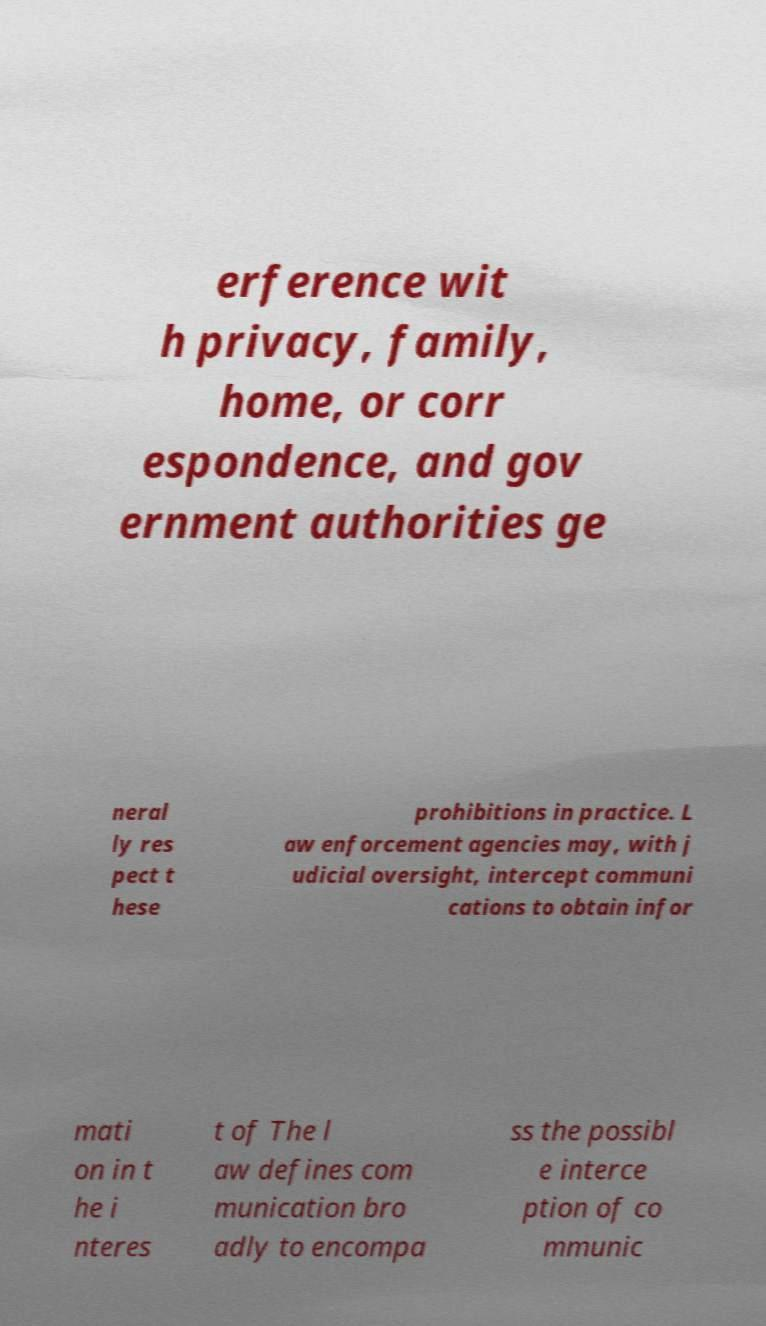Can you read and provide the text displayed in the image?This photo seems to have some interesting text. Can you extract and type it out for me? erference wit h privacy, family, home, or corr espondence, and gov ernment authorities ge neral ly res pect t hese prohibitions in practice. L aw enforcement agencies may, with j udicial oversight, intercept communi cations to obtain infor mati on in t he i nteres t of The l aw defines com munication bro adly to encompa ss the possibl e interce ption of co mmunic 